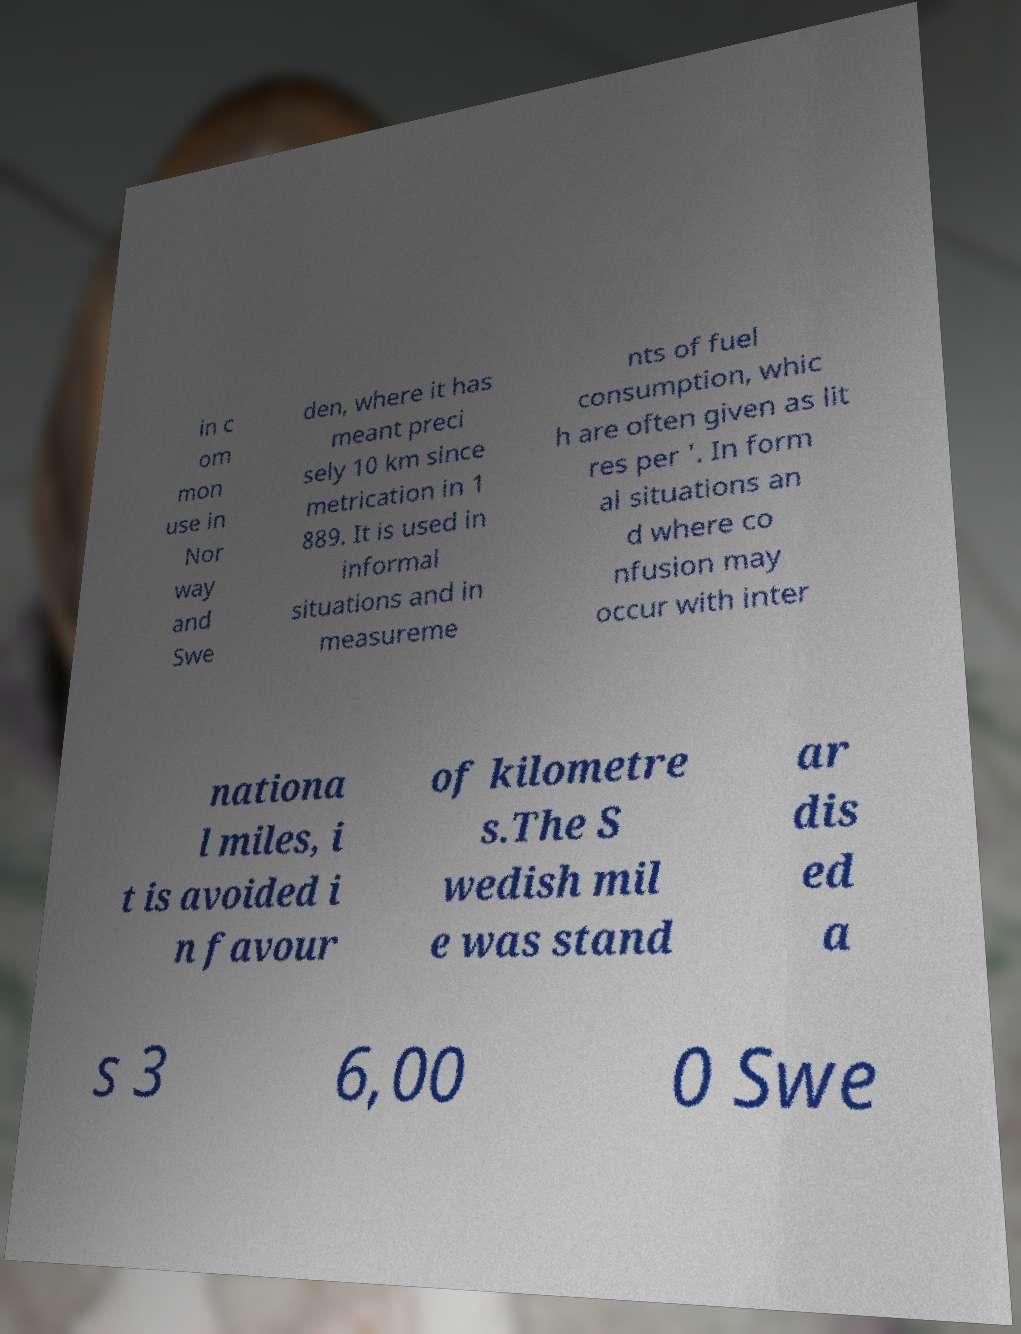Please read and relay the text visible in this image. What does it say? in c om mon use in Nor way and Swe den, where it has meant preci sely 10 km since metrication in 1 889. It is used in informal situations and in measureme nts of fuel consumption, whic h are often given as lit res per '. In form al situations an d where co nfusion may occur with inter nationa l miles, i t is avoided i n favour of kilometre s.The S wedish mil e was stand ar dis ed a s 3 6,00 0 Swe 